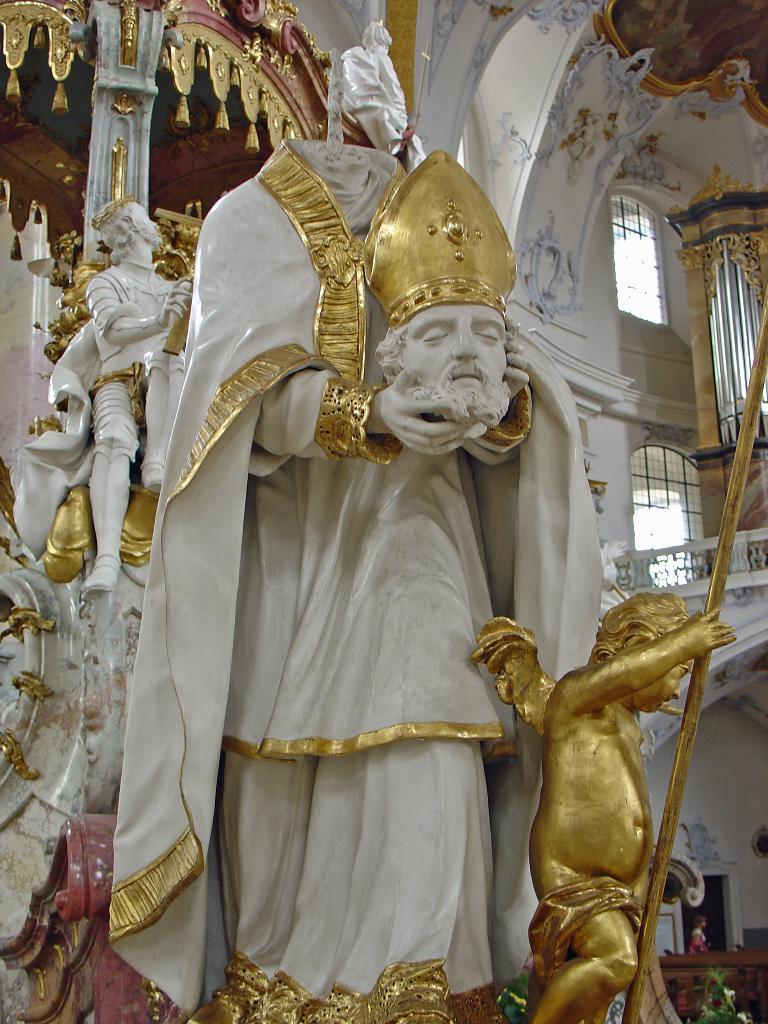Could you give a brief overview of what you see in this image? In the center of the image there is a statue. In the background we can see statues, windows, door, person and wall. 